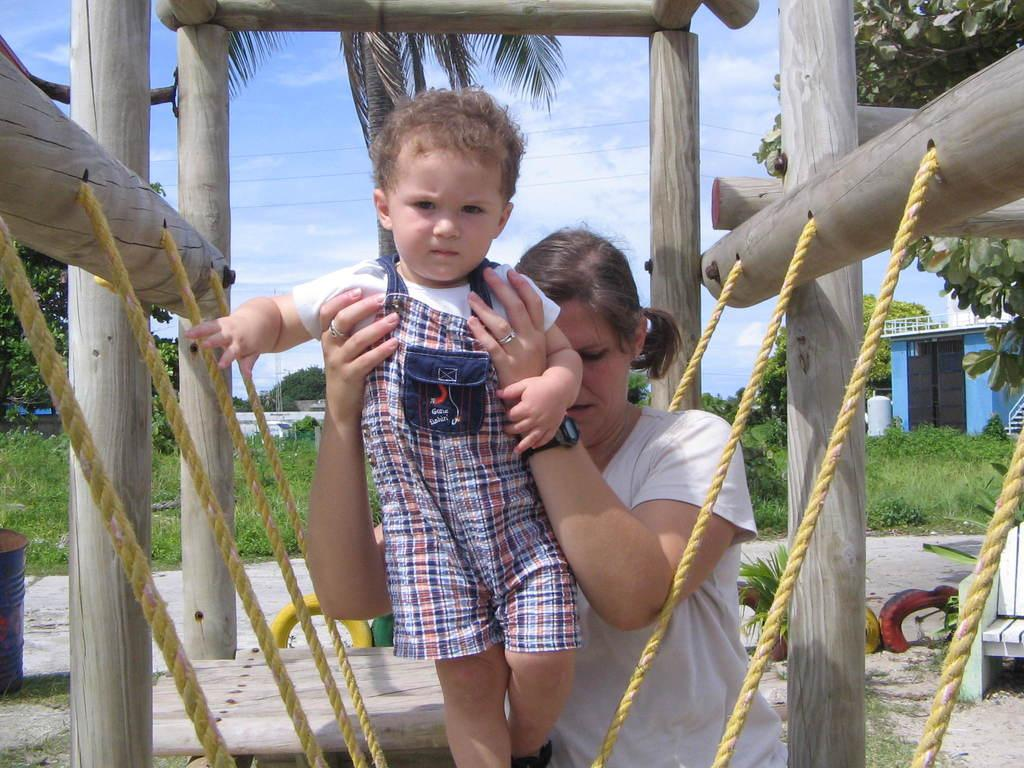What is the woman in the image doing? The woman is holding a child in the image. What can be seen in the background of the image? There is a wooden fence, buildings, houseplants, bins, chairs, a shed, electric cables, bushes, trees, and the sky visible in the image. What is the condition of the sky in the image? The sky is visible in the image, and there are clouds present. What type of mask is the child wearing in the image? There is no mask present on the child in the image. How many giants can be seen interacting with the houseplants in the image? There are no giants present in the image; it features a woman holding a child and various objects and structures in the background. 